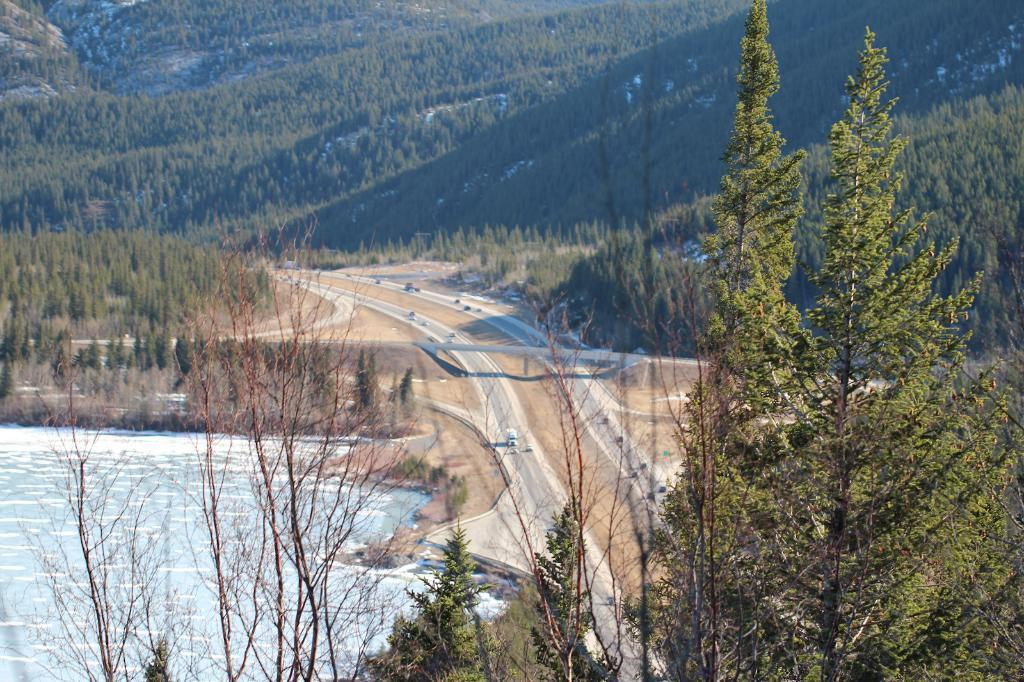What type of transportation can be seen on the roads in the image? There are motor vehicles on the roads in the image. What natural feature is present in the image? There is a river in the image. What type of geographical feature can be seen in the image? There are hills in the image. What type of vegetation is present in the image? There are trees in the image. What type of mailbox can be seen near the river in the image? There is no mailbox present in the image. What type of smell can be detected from the trees in the image? The image is a visual representation, and therefore, it does not convey smells. 